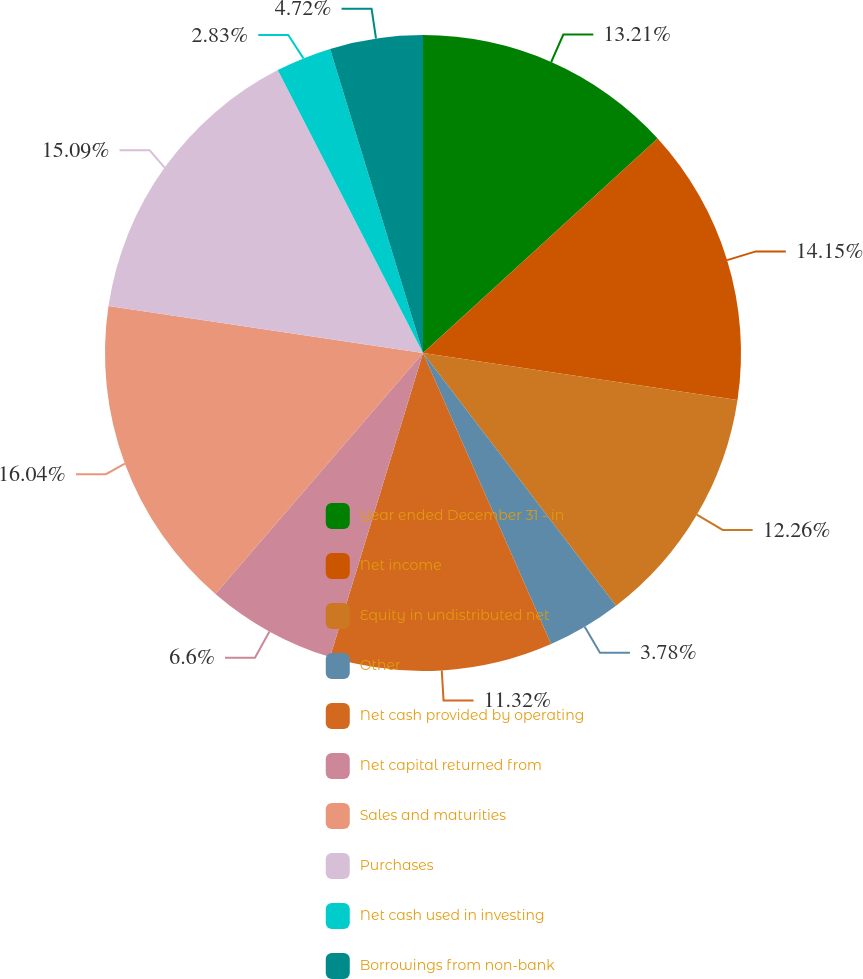Convert chart to OTSL. <chart><loc_0><loc_0><loc_500><loc_500><pie_chart><fcel>Year ended December 31 - in<fcel>Net income<fcel>Equity in undistributed net<fcel>Other<fcel>Net cash provided by operating<fcel>Net capital returned from<fcel>Sales and maturities<fcel>Purchases<fcel>Net cash used in investing<fcel>Borrowings from non-bank<nl><fcel>13.21%<fcel>14.15%<fcel>12.26%<fcel>3.78%<fcel>11.32%<fcel>6.6%<fcel>16.04%<fcel>15.09%<fcel>2.83%<fcel>4.72%<nl></chart> 